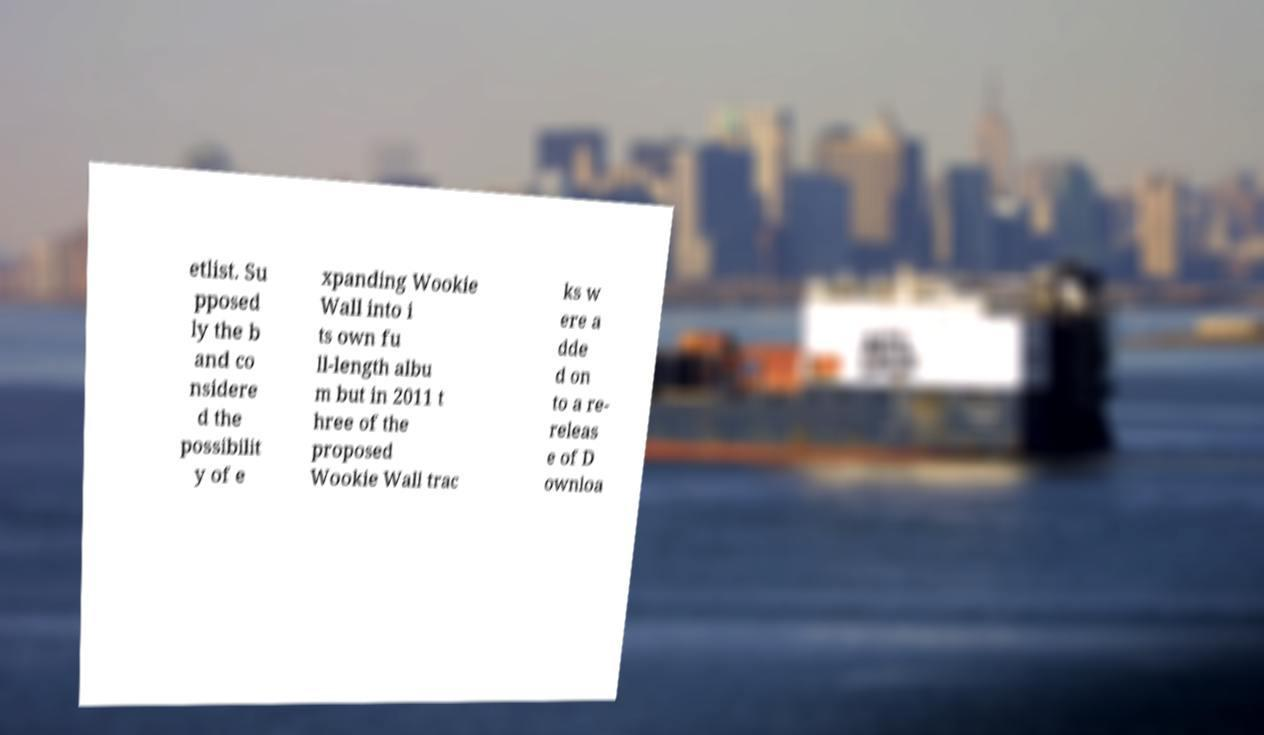There's text embedded in this image that I need extracted. Can you transcribe it verbatim? etlist. Su pposed ly the b and co nsidere d the possibilit y of e xpanding Wookie Wall into i ts own fu ll-length albu m but in 2011 t hree of the proposed Wookie Wall trac ks w ere a dde d on to a re- releas e of D ownloa 